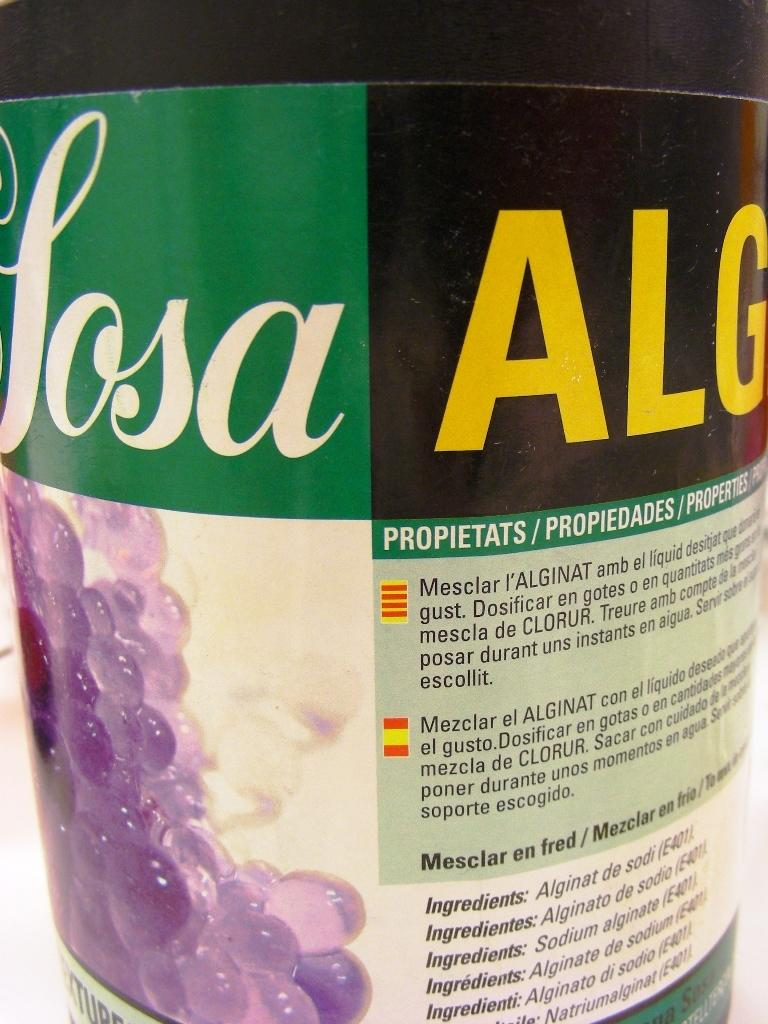What is located in the foreground of the image? There is a bottle in the foreground of the image. What can be seen on the bottle? There is text on the bottle. What other objects are near the bottle? There are balls near the bottle. Is the bottle sinking in quicksand in the image? There is no quicksand present in the image, and the bottle is not sinking. What type of jelly is being used topped with the balls in the image? There is no jelly present in the image; it features a bottle with text and nearby balls. 